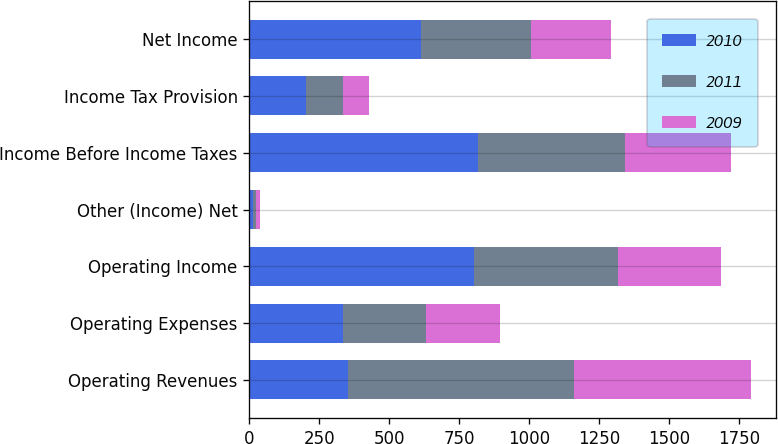Convert chart. <chart><loc_0><loc_0><loc_500><loc_500><stacked_bar_chart><ecel><fcel>Operating Revenues<fcel>Operating Expenses<fcel>Operating Income<fcel>Other (Income) Net<fcel>Income Before Income Taxes<fcel>Income Tax Provision<fcel>Net Income<nl><fcel>2010<fcel>351.5<fcel>335<fcel>804<fcel>12<fcel>816<fcel>201<fcel>615<nl><fcel>2011<fcel>809<fcel>296<fcel>513<fcel>12<fcel>525<fcel>133<fcel>392<nl><fcel>2009<fcel>632<fcel>264<fcel>368<fcel>13<fcel>381<fcel>95<fcel>286<nl></chart> 